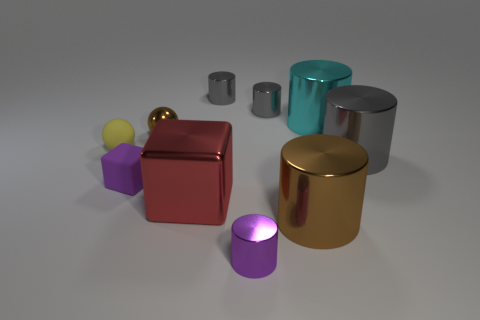Is the shape of the small yellow object the same as the big gray thing?
Offer a very short reply. No. What color is the tiny matte ball?
Give a very brief answer. Yellow. What is the gray cylinder that is to the right of the tiny metallic cylinder right of the small cylinder in front of the large gray object made of?
Your answer should be compact. Metal. There is a sphere that is the same material as the small cube; what size is it?
Offer a terse response. Small. Are there any big cubes of the same color as the shiny ball?
Make the answer very short. No. There is a cyan cylinder; is it the same size as the block to the left of the metallic block?
Your response must be concise. No. There is a rubber object to the right of the small yellow rubber object that is behind the tiny purple rubber thing; how many big objects are behind it?
Your response must be concise. 2. What size is the thing that is the same color as the tiny metallic sphere?
Your response must be concise. Large. Are there any big red objects to the right of the red object?
Provide a short and direct response. No. What is the shape of the large red metallic object?
Keep it short and to the point. Cube. 